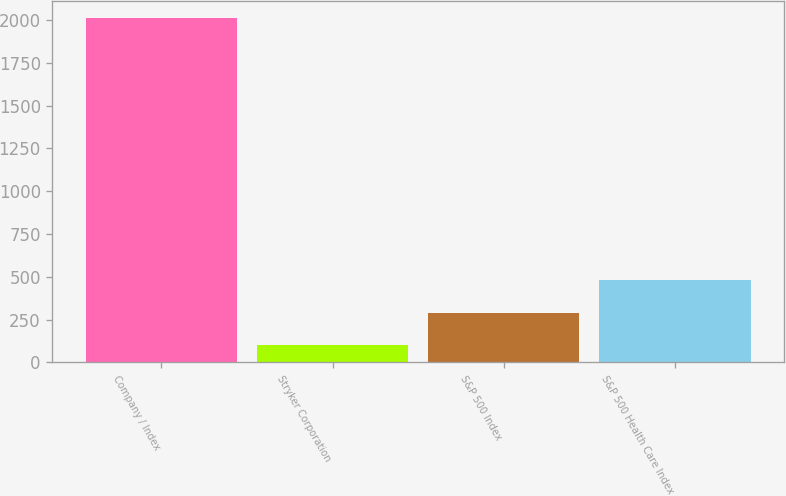<chart> <loc_0><loc_0><loc_500><loc_500><bar_chart><fcel>Company / Index<fcel>Stryker Corporation<fcel>S&P 500 Index<fcel>S&P 500 Health Care Index<nl><fcel>2010<fcel>100<fcel>291<fcel>482<nl></chart> 